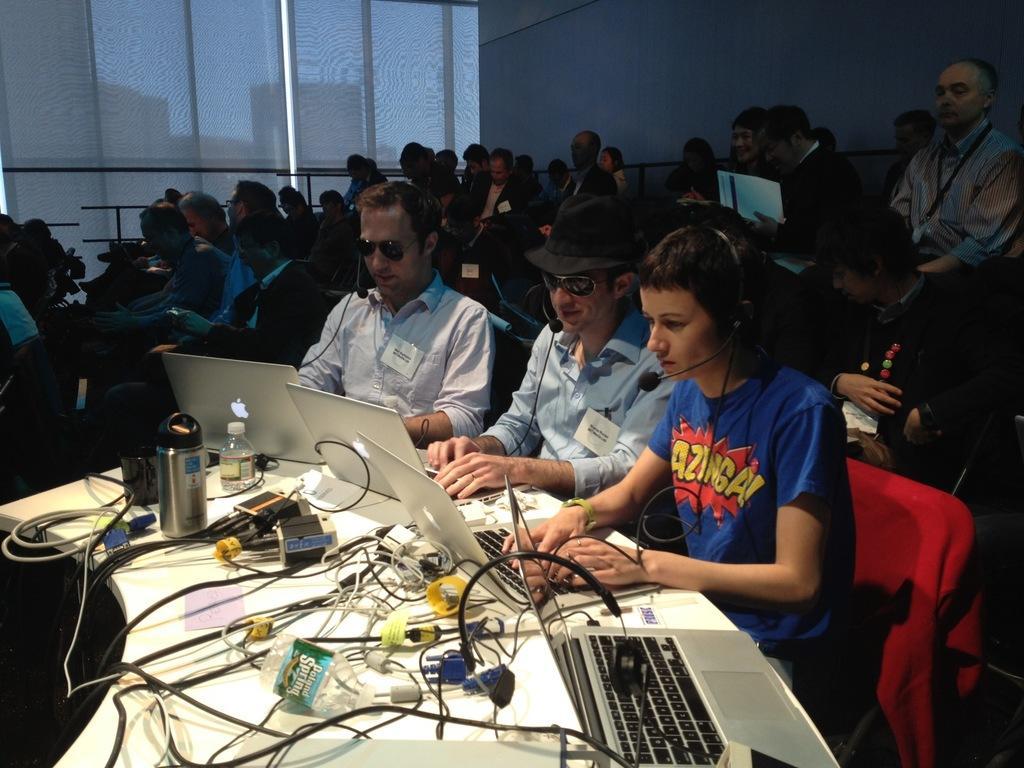How would you summarize this image in a sentence or two? In this image there are group of people sitting on chairs beside the glass wall in front of table where we can see there is a laptop connected with cables and some other objects. 